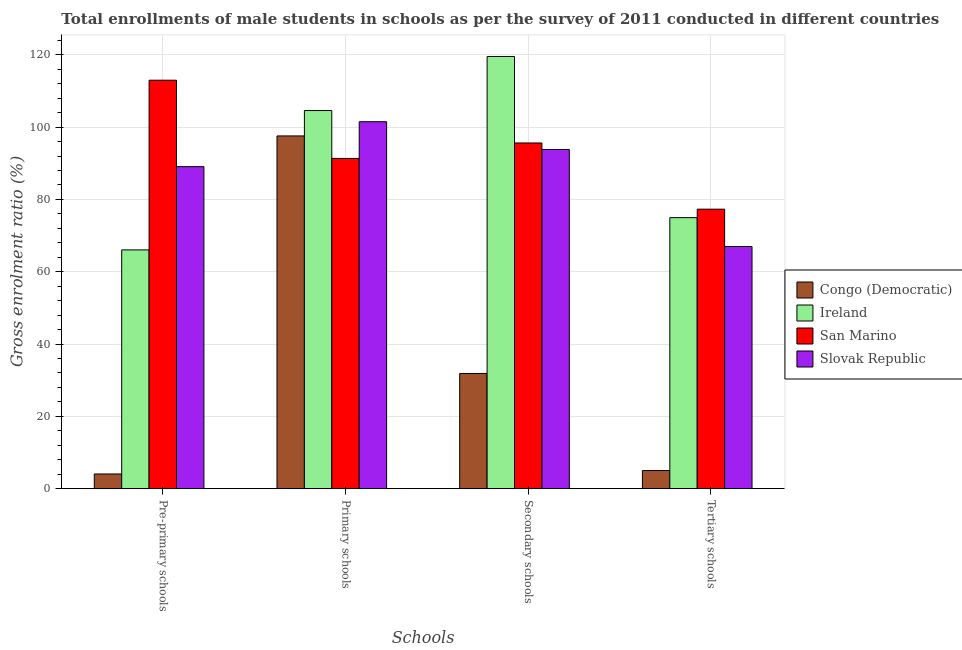How many groups of bars are there?
Make the answer very short. 4. How many bars are there on the 3rd tick from the left?
Keep it short and to the point. 4. What is the label of the 3rd group of bars from the left?
Your answer should be very brief. Secondary schools. What is the gross enrolment ratio(male) in tertiary schools in San Marino?
Your response must be concise. 77.3. Across all countries, what is the maximum gross enrolment ratio(male) in secondary schools?
Your response must be concise. 119.54. Across all countries, what is the minimum gross enrolment ratio(male) in pre-primary schools?
Make the answer very short. 4.07. In which country was the gross enrolment ratio(male) in primary schools maximum?
Make the answer very short. Ireland. In which country was the gross enrolment ratio(male) in primary schools minimum?
Offer a very short reply. San Marino. What is the total gross enrolment ratio(male) in primary schools in the graph?
Keep it short and to the point. 394.98. What is the difference between the gross enrolment ratio(male) in pre-primary schools in San Marino and that in Congo (Democratic)?
Make the answer very short. 108.91. What is the difference between the gross enrolment ratio(male) in secondary schools in Ireland and the gross enrolment ratio(male) in primary schools in Congo (Democratic)?
Ensure brevity in your answer.  21.97. What is the average gross enrolment ratio(male) in primary schools per country?
Keep it short and to the point. 98.75. What is the difference between the gross enrolment ratio(male) in pre-primary schools and gross enrolment ratio(male) in tertiary schools in San Marino?
Provide a short and direct response. 35.67. What is the ratio of the gross enrolment ratio(male) in tertiary schools in Congo (Democratic) to that in Ireland?
Your response must be concise. 0.07. What is the difference between the highest and the second highest gross enrolment ratio(male) in tertiary schools?
Your answer should be very brief. 2.34. What is the difference between the highest and the lowest gross enrolment ratio(male) in secondary schools?
Give a very brief answer. 87.67. Is it the case that in every country, the sum of the gross enrolment ratio(male) in secondary schools and gross enrolment ratio(male) in tertiary schools is greater than the sum of gross enrolment ratio(male) in primary schools and gross enrolment ratio(male) in pre-primary schools?
Your answer should be compact. No. What does the 1st bar from the left in Pre-primary schools represents?
Give a very brief answer. Congo (Democratic). What does the 3rd bar from the right in Pre-primary schools represents?
Give a very brief answer. Ireland. Are the values on the major ticks of Y-axis written in scientific E-notation?
Your response must be concise. No. Does the graph contain any zero values?
Offer a very short reply. No. Does the graph contain grids?
Offer a very short reply. Yes. How many legend labels are there?
Your answer should be compact. 4. What is the title of the graph?
Give a very brief answer. Total enrollments of male students in schools as per the survey of 2011 conducted in different countries. What is the label or title of the X-axis?
Your answer should be compact. Schools. What is the label or title of the Y-axis?
Provide a short and direct response. Gross enrolment ratio (%). What is the Gross enrolment ratio (%) of Congo (Democratic) in Pre-primary schools?
Your answer should be compact. 4.07. What is the Gross enrolment ratio (%) of Ireland in Pre-primary schools?
Offer a terse response. 66.04. What is the Gross enrolment ratio (%) in San Marino in Pre-primary schools?
Offer a very short reply. 112.98. What is the Gross enrolment ratio (%) of Slovak Republic in Pre-primary schools?
Your answer should be very brief. 89.07. What is the Gross enrolment ratio (%) of Congo (Democratic) in Primary schools?
Ensure brevity in your answer.  97.57. What is the Gross enrolment ratio (%) in Ireland in Primary schools?
Keep it short and to the point. 104.59. What is the Gross enrolment ratio (%) in San Marino in Primary schools?
Make the answer very short. 91.34. What is the Gross enrolment ratio (%) in Slovak Republic in Primary schools?
Your answer should be very brief. 101.49. What is the Gross enrolment ratio (%) in Congo (Democratic) in Secondary schools?
Offer a very short reply. 31.86. What is the Gross enrolment ratio (%) in Ireland in Secondary schools?
Offer a terse response. 119.54. What is the Gross enrolment ratio (%) in San Marino in Secondary schools?
Offer a very short reply. 95.62. What is the Gross enrolment ratio (%) in Slovak Republic in Secondary schools?
Your response must be concise. 93.82. What is the Gross enrolment ratio (%) in Congo (Democratic) in Tertiary schools?
Offer a very short reply. 5.01. What is the Gross enrolment ratio (%) in Ireland in Tertiary schools?
Provide a succinct answer. 74.96. What is the Gross enrolment ratio (%) of San Marino in Tertiary schools?
Your response must be concise. 77.3. What is the Gross enrolment ratio (%) in Slovak Republic in Tertiary schools?
Offer a very short reply. 66.99. Across all Schools, what is the maximum Gross enrolment ratio (%) in Congo (Democratic)?
Your response must be concise. 97.57. Across all Schools, what is the maximum Gross enrolment ratio (%) in Ireland?
Your answer should be compact. 119.54. Across all Schools, what is the maximum Gross enrolment ratio (%) in San Marino?
Your answer should be compact. 112.98. Across all Schools, what is the maximum Gross enrolment ratio (%) in Slovak Republic?
Make the answer very short. 101.49. Across all Schools, what is the minimum Gross enrolment ratio (%) in Congo (Democratic)?
Your answer should be very brief. 4.07. Across all Schools, what is the minimum Gross enrolment ratio (%) of Ireland?
Offer a terse response. 66.04. Across all Schools, what is the minimum Gross enrolment ratio (%) of San Marino?
Your answer should be compact. 77.3. Across all Schools, what is the minimum Gross enrolment ratio (%) in Slovak Republic?
Offer a terse response. 66.99. What is the total Gross enrolment ratio (%) of Congo (Democratic) in the graph?
Provide a short and direct response. 138.51. What is the total Gross enrolment ratio (%) of Ireland in the graph?
Your response must be concise. 365.13. What is the total Gross enrolment ratio (%) in San Marino in the graph?
Offer a very short reply. 377.23. What is the total Gross enrolment ratio (%) of Slovak Republic in the graph?
Your answer should be compact. 351.37. What is the difference between the Gross enrolment ratio (%) of Congo (Democratic) in Pre-primary schools and that in Primary schools?
Provide a succinct answer. -93.5. What is the difference between the Gross enrolment ratio (%) of Ireland in Pre-primary schools and that in Primary schools?
Ensure brevity in your answer.  -38.54. What is the difference between the Gross enrolment ratio (%) of San Marino in Pre-primary schools and that in Primary schools?
Your response must be concise. 21.64. What is the difference between the Gross enrolment ratio (%) of Slovak Republic in Pre-primary schools and that in Primary schools?
Provide a succinct answer. -12.43. What is the difference between the Gross enrolment ratio (%) of Congo (Democratic) in Pre-primary schools and that in Secondary schools?
Ensure brevity in your answer.  -27.8. What is the difference between the Gross enrolment ratio (%) of Ireland in Pre-primary schools and that in Secondary schools?
Your answer should be very brief. -53.49. What is the difference between the Gross enrolment ratio (%) of San Marino in Pre-primary schools and that in Secondary schools?
Offer a terse response. 17.36. What is the difference between the Gross enrolment ratio (%) in Slovak Republic in Pre-primary schools and that in Secondary schools?
Make the answer very short. -4.76. What is the difference between the Gross enrolment ratio (%) in Congo (Democratic) in Pre-primary schools and that in Tertiary schools?
Ensure brevity in your answer.  -0.94. What is the difference between the Gross enrolment ratio (%) in Ireland in Pre-primary schools and that in Tertiary schools?
Provide a succinct answer. -8.92. What is the difference between the Gross enrolment ratio (%) of San Marino in Pre-primary schools and that in Tertiary schools?
Your answer should be compact. 35.67. What is the difference between the Gross enrolment ratio (%) in Slovak Republic in Pre-primary schools and that in Tertiary schools?
Provide a short and direct response. 22.08. What is the difference between the Gross enrolment ratio (%) in Congo (Democratic) in Primary schools and that in Secondary schools?
Offer a very short reply. 65.7. What is the difference between the Gross enrolment ratio (%) in Ireland in Primary schools and that in Secondary schools?
Your answer should be compact. -14.95. What is the difference between the Gross enrolment ratio (%) in San Marino in Primary schools and that in Secondary schools?
Your answer should be compact. -4.28. What is the difference between the Gross enrolment ratio (%) of Slovak Republic in Primary schools and that in Secondary schools?
Your response must be concise. 7.67. What is the difference between the Gross enrolment ratio (%) in Congo (Democratic) in Primary schools and that in Tertiary schools?
Keep it short and to the point. 92.55. What is the difference between the Gross enrolment ratio (%) in Ireland in Primary schools and that in Tertiary schools?
Ensure brevity in your answer.  29.63. What is the difference between the Gross enrolment ratio (%) in San Marino in Primary schools and that in Tertiary schools?
Your answer should be compact. 14.03. What is the difference between the Gross enrolment ratio (%) in Slovak Republic in Primary schools and that in Tertiary schools?
Provide a succinct answer. 34.51. What is the difference between the Gross enrolment ratio (%) in Congo (Democratic) in Secondary schools and that in Tertiary schools?
Your answer should be very brief. 26.85. What is the difference between the Gross enrolment ratio (%) in Ireland in Secondary schools and that in Tertiary schools?
Provide a short and direct response. 44.58. What is the difference between the Gross enrolment ratio (%) of San Marino in Secondary schools and that in Tertiary schools?
Make the answer very short. 18.31. What is the difference between the Gross enrolment ratio (%) in Slovak Republic in Secondary schools and that in Tertiary schools?
Ensure brevity in your answer.  26.84. What is the difference between the Gross enrolment ratio (%) of Congo (Democratic) in Pre-primary schools and the Gross enrolment ratio (%) of Ireland in Primary schools?
Your answer should be very brief. -100.52. What is the difference between the Gross enrolment ratio (%) of Congo (Democratic) in Pre-primary schools and the Gross enrolment ratio (%) of San Marino in Primary schools?
Your answer should be very brief. -87.27. What is the difference between the Gross enrolment ratio (%) in Congo (Democratic) in Pre-primary schools and the Gross enrolment ratio (%) in Slovak Republic in Primary schools?
Provide a succinct answer. -97.43. What is the difference between the Gross enrolment ratio (%) in Ireland in Pre-primary schools and the Gross enrolment ratio (%) in San Marino in Primary schools?
Your answer should be very brief. -25.29. What is the difference between the Gross enrolment ratio (%) in Ireland in Pre-primary schools and the Gross enrolment ratio (%) in Slovak Republic in Primary schools?
Your answer should be very brief. -35.45. What is the difference between the Gross enrolment ratio (%) in San Marino in Pre-primary schools and the Gross enrolment ratio (%) in Slovak Republic in Primary schools?
Keep it short and to the point. 11.48. What is the difference between the Gross enrolment ratio (%) of Congo (Democratic) in Pre-primary schools and the Gross enrolment ratio (%) of Ireland in Secondary schools?
Provide a short and direct response. -115.47. What is the difference between the Gross enrolment ratio (%) in Congo (Democratic) in Pre-primary schools and the Gross enrolment ratio (%) in San Marino in Secondary schools?
Ensure brevity in your answer.  -91.55. What is the difference between the Gross enrolment ratio (%) in Congo (Democratic) in Pre-primary schools and the Gross enrolment ratio (%) in Slovak Republic in Secondary schools?
Your response must be concise. -89.76. What is the difference between the Gross enrolment ratio (%) in Ireland in Pre-primary schools and the Gross enrolment ratio (%) in San Marino in Secondary schools?
Your answer should be compact. -29.57. What is the difference between the Gross enrolment ratio (%) of Ireland in Pre-primary schools and the Gross enrolment ratio (%) of Slovak Republic in Secondary schools?
Your answer should be very brief. -27.78. What is the difference between the Gross enrolment ratio (%) of San Marino in Pre-primary schools and the Gross enrolment ratio (%) of Slovak Republic in Secondary schools?
Give a very brief answer. 19.15. What is the difference between the Gross enrolment ratio (%) in Congo (Democratic) in Pre-primary schools and the Gross enrolment ratio (%) in Ireland in Tertiary schools?
Provide a succinct answer. -70.89. What is the difference between the Gross enrolment ratio (%) in Congo (Democratic) in Pre-primary schools and the Gross enrolment ratio (%) in San Marino in Tertiary schools?
Provide a short and direct response. -73.24. What is the difference between the Gross enrolment ratio (%) in Congo (Democratic) in Pre-primary schools and the Gross enrolment ratio (%) in Slovak Republic in Tertiary schools?
Keep it short and to the point. -62.92. What is the difference between the Gross enrolment ratio (%) in Ireland in Pre-primary schools and the Gross enrolment ratio (%) in San Marino in Tertiary schools?
Make the answer very short. -11.26. What is the difference between the Gross enrolment ratio (%) in Ireland in Pre-primary schools and the Gross enrolment ratio (%) in Slovak Republic in Tertiary schools?
Keep it short and to the point. -0.94. What is the difference between the Gross enrolment ratio (%) of San Marino in Pre-primary schools and the Gross enrolment ratio (%) of Slovak Republic in Tertiary schools?
Provide a short and direct response. 45.99. What is the difference between the Gross enrolment ratio (%) of Congo (Democratic) in Primary schools and the Gross enrolment ratio (%) of Ireland in Secondary schools?
Ensure brevity in your answer.  -21.97. What is the difference between the Gross enrolment ratio (%) of Congo (Democratic) in Primary schools and the Gross enrolment ratio (%) of San Marino in Secondary schools?
Provide a succinct answer. 1.95. What is the difference between the Gross enrolment ratio (%) of Congo (Democratic) in Primary schools and the Gross enrolment ratio (%) of Slovak Republic in Secondary schools?
Keep it short and to the point. 3.74. What is the difference between the Gross enrolment ratio (%) in Ireland in Primary schools and the Gross enrolment ratio (%) in San Marino in Secondary schools?
Your response must be concise. 8.97. What is the difference between the Gross enrolment ratio (%) of Ireland in Primary schools and the Gross enrolment ratio (%) of Slovak Republic in Secondary schools?
Keep it short and to the point. 10.76. What is the difference between the Gross enrolment ratio (%) in San Marino in Primary schools and the Gross enrolment ratio (%) in Slovak Republic in Secondary schools?
Offer a terse response. -2.49. What is the difference between the Gross enrolment ratio (%) in Congo (Democratic) in Primary schools and the Gross enrolment ratio (%) in Ireland in Tertiary schools?
Your answer should be compact. 22.6. What is the difference between the Gross enrolment ratio (%) of Congo (Democratic) in Primary schools and the Gross enrolment ratio (%) of San Marino in Tertiary schools?
Your response must be concise. 20.26. What is the difference between the Gross enrolment ratio (%) of Congo (Democratic) in Primary schools and the Gross enrolment ratio (%) of Slovak Republic in Tertiary schools?
Offer a very short reply. 30.58. What is the difference between the Gross enrolment ratio (%) in Ireland in Primary schools and the Gross enrolment ratio (%) in San Marino in Tertiary schools?
Offer a terse response. 27.28. What is the difference between the Gross enrolment ratio (%) of Ireland in Primary schools and the Gross enrolment ratio (%) of Slovak Republic in Tertiary schools?
Provide a succinct answer. 37.6. What is the difference between the Gross enrolment ratio (%) of San Marino in Primary schools and the Gross enrolment ratio (%) of Slovak Republic in Tertiary schools?
Ensure brevity in your answer.  24.35. What is the difference between the Gross enrolment ratio (%) of Congo (Democratic) in Secondary schools and the Gross enrolment ratio (%) of Ireland in Tertiary schools?
Ensure brevity in your answer.  -43.1. What is the difference between the Gross enrolment ratio (%) of Congo (Democratic) in Secondary schools and the Gross enrolment ratio (%) of San Marino in Tertiary schools?
Your response must be concise. -45.44. What is the difference between the Gross enrolment ratio (%) in Congo (Democratic) in Secondary schools and the Gross enrolment ratio (%) in Slovak Republic in Tertiary schools?
Give a very brief answer. -35.12. What is the difference between the Gross enrolment ratio (%) of Ireland in Secondary schools and the Gross enrolment ratio (%) of San Marino in Tertiary schools?
Provide a succinct answer. 42.23. What is the difference between the Gross enrolment ratio (%) in Ireland in Secondary schools and the Gross enrolment ratio (%) in Slovak Republic in Tertiary schools?
Your response must be concise. 52.55. What is the difference between the Gross enrolment ratio (%) in San Marino in Secondary schools and the Gross enrolment ratio (%) in Slovak Republic in Tertiary schools?
Offer a very short reply. 28.63. What is the average Gross enrolment ratio (%) of Congo (Democratic) per Schools?
Provide a succinct answer. 34.63. What is the average Gross enrolment ratio (%) in Ireland per Schools?
Offer a terse response. 91.28. What is the average Gross enrolment ratio (%) in San Marino per Schools?
Your answer should be very brief. 94.31. What is the average Gross enrolment ratio (%) of Slovak Republic per Schools?
Offer a terse response. 87.84. What is the difference between the Gross enrolment ratio (%) in Congo (Democratic) and Gross enrolment ratio (%) in Ireland in Pre-primary schools?
Your response must be concise. -61.97. What is the difference between the Gross enrolment ratio (%) of Congo (Democratic) and Gross enrolment ratio (%) of San Marino in Pre-primary schools?
Provide a short and direct response. -108.91. What is the difference between the Gross enrolment ratio (%) in Congo (Democratic) and Gross enrolment ratio (%) in Slovak Republic in Pre-primary schools?
Offer a very short reply. -85. What is the difference between the Gross enrolment ratio (%) in Ireland and Gross enrolment ratio (%) in San Marino in Pre-primary schools?
Give a very brief answer. -46.93. What is the difference between the Gross enrolment ratio (%) in Ireland and Gross enrolment ratio (%) in Slovak Republic in Pre-primary schools?
Provide a short and direct response. -23.02. What is the difference between the Gross enrolment ratio (%) in San Marino and Gross enrolment ratio (%) in Slovak Republic in Pre-primary schools?
Keep it short and to the point. 23.91. What is the difference between the Gross enrolment ratio (%) of Congo (Democratic) and Gross enrolment ratio (%) of Ireland in Primary schools?
Your response must be concise. -7.02. What is the difference between the Gross enrolment ratio (%) in Congo (Democratic) and Gross enrolment ratio (%) in San Marino in Primary schools?
Your answer should be compact. 6.23. What is the difference between the Gross enrolment ratio (%) of Congo (Democratic) and Gross enrolment ratio (%) of Slovak Republic in Primary schools?
Ensure brevity in your answer.  -3.93. What is the difference between the Gross enrolment ratio (%) of Ireland and Gross enrolment ratio (%) of San Marino in Primary schools?
Provide a succinct answer. 13.25. What is the difference between the Gross enrolment ratio (%) in Ireland and Gross enrolment ratio (%) in Slovak Republic in Primary schools?
Give a very brief answer. 3.09. What is the difference between the Gross enrolment ratio (%) in San Marino and Gross enrolment ratio (%) in Slovak Republic in Primary schools?
Provide a short and direct response. -10.16. What is the difference between the Gross enrolment ratio (%) in Congo (Democratic) and Gross enrolment ratio (%) in Ireland in Secondary schools?
Offer a terse response. -87.67. What is the difference between the Gross enrolment ratio (%) of Congo (Democratic) and Gross enrolment ratio (%) of San Marino in Secondary schools?
Ensure brevity in your answer.  -63.75. What is the difference between the Gross enrolment ratio (%) in Congo (Democratic) and Gross enrolment ratio (%) in Slovak Republic in Secondary schools?
Keep it short and to the point. -61.96. What is the difference between the Gross enrolment ratio (%) of Ireland and Gross enrolment ratio (%) of San Marino in Secondary schools?
Your answer should be compact. 23.92. What is the difference between the Gross enrolment ratio (%) in Ireland and Gross enrolment ratio (%) in Slovak Republic in Secondary schools?
Your answer should be compact. 25.71. What is the difference between the Gross enrolment ratio (%) in San Marino and Gross enrolment ratio (%) in Slovak Republic in Secondary schools?
Provide a short and direct response. 1.79. What is the difference between the Gross enrolment ratio (%) of Congo (Democratic) and Gross enrolment ratio (%) of Ireland in Tertiary schools?
Keep it short and to the point. -69.95. What is the difference between the Gross enrolment ratio (%) of Congo (Democratic) and Gross enrolment ratio (%) of San Marino in Tertiary schools?
Give a very brief answer. -72.29. What is the difference between the Gross enrolment ratio (%) in Congo (Democratic) and Gross enrolment ratio (%) in Slovak Republic in Tertiary schools?
Ensure brevity in your answer.  -61.97. What is the difference between the Gross enrolment ratio (%) in Ireland and Gross enrolment ratio (%) in San Marino in Tertiary schools?
Your answer should be very brief. -2.34. What is the difference between the Gross enrolment ratio (%) in Ireland and Gross enrolment ratio (%) in Slovak Republic in Tertiary schools?
Your answer should be very brief. 7.97. What is the difference between the Gross enrolment ratio (%) of San Marino and Gross enrolment ratio (%) of Slovak Republic in Tertiary schools?
Offer a very short reply. 10.32. What is the ratio of the Gross enrolment ratio (%) of Congo (Democratic) in Pre-primary schools to that in Primary schools?
Your answer should be compact. 0.04. What is the ratio of the Gross enrolment ratio (%) in Ireland in Pre-primary schools to that in Primary schools?
Provide a succinct answer. 0.63. What is the ratio of the Gross enrolment ratio (%) of San Marino in Pre-primary schools to that in Primary schools?
Ensure brevity in your answer.  1.24. What is the ratio of the Gross enrolment ratio (%) in Slovak Republic in Pre-primary schools to that in Primary schools?
Your answer should be very brief. 0.88. What is the ratio of the Gross enrolment ratio (%) of Congo (Democratic) in Pre-primary schools to that in Secondary schools?
Your response must be concise. 0.13. What is the ratio of the Gross enrolment ratio (%) in Ireland in Pre-primary schools to that in Secondary schools?
Your response must be concise. 0.55. What is the ratio of the Gross enrolment ratio (%) in San Marino in Pre-primary schools to that in Secondary schools?
Give a very brief answer. 1.18. What is the ratio of the Gross enrolment ratio (%) in Slovak Republic in Pre-primary schools to that in Secondary schools?
Your response must be concise. 0.95. What is the ratio of the Gross enrolment ratio (%) of Congo (Democratic) in Pre-primary schools to that in Tertiary schools?
Give a very brief answer. 0.81. What is the ratio of the Gross enrolment ratio (%) in Ireland in Pre-primary schools to that in Tertiary schools?
Provide a short and direct response. 0.88. What is the ratio of the Gross enrolment ratio (%) of San Marino in Pre-primary schools to that in Tertiary schools?
Your answer should be very brief. 1.46. What is the ratio of the Gross enrolment ratio (%) in Slovak Republic in Pre-primary schools to that in Tertiary schools?
Offer a terse response. 1.33. What is the ratio of the Gross enrolment ratio (%) in Congo (Democratic) in Primary schools to that in Secondary schools?
Provide a short and direct response. 3.06. What is the ratio of the Gross enrolment ratio (%) of Ireland in Primary schools to that in Secondary schools?
Ensure brevity in your answer.  0.87. What is the ratio of the Gross enrolment ratio (%) of San Marino in Primary schools to that in Secondary schools?
Provide a succinct answer. 0.96. What is the ratio of the Gross enrolment ratio (%) of Slovak Republic in Primary schools to that in Secondary schools?
Provide a succinct answer. 1.08. What is the ratio of the Gross enrolment ratio (%) of Congo (Democratic) in Primary schools to that in Tertiary schools?
Make the answer very short. 19.47. What is the ratio of the Gross enrolment ratio (%) in Ireland in Primary schools to that in Tertiary schools?
Keep it short and to the point. 1.4. What is the ratio of the Gross enrolment ratio (%) in San Marino in Primary schools to that in Tertiary schools?
Offer a terse response. 1.18. What is the ratio of the Gross enrolment ratio (%) in Slovak Republic in Primary schools to that in Tertiary schools?
Ensure brevity in your answer.  1.52. What is the ratio of the Gross enrolment ratio (%) of Congo (Democratic) in Secondary schools to that in Tertiary schools?
Provide a short and direct response. 6.36. What is the ratio of the Gross enrolment ratio (%) of Ireland in Secondary schools to that in Tertiary schools?
Provide a short and direct response. 1.59. What is the ratio of the Gross enrolment ratio (%) of San Marino in Secondary schools to that in Tertiary schools?
Provide a short and direct response. 1.24. What is the ratio of the Gross enrolment ratio (%) of Slovak Republic in Secondary schools to that in Tertiary schools?
Offer a very short reply. 1.4. What is the difference between the highest and the second highest Gross enrolment ratio (%) in Congo (Democratic)?
Keep it short and to the point. 65.7. What is the difference between the highest and the second highest Gross enrolment ratio (%) of Ireland?
Give a very brief answer. 14.95. What is the difference between the highest and the second highest Gross enrolment ratio (%) of San Marino?
Your answer should be compact. 17.36. What is the difference between the highest and the second highest Gross enrolment ratio (%) in Slovak Republic?
Make the answer very short. 7.67. What is the difference between the highest and the lowest Gross enrolment ratio (%) in Congo (Democratic)?
Your answer should be compact. 93.5. What is the difference between the highest and the lowest Gross enrolment ratio (%) in Ireland?
Your answer should be very brief. 53.49. What is the difference between the highest and the lowest Gross enrolment ratio (%) in San Marino?
Offer a very short reply. 35.67. What is the difference between the highest and the lowest Gross enrolment ratio (%) of Slovak Republic?
Provide a short and direct response. 34.51. 